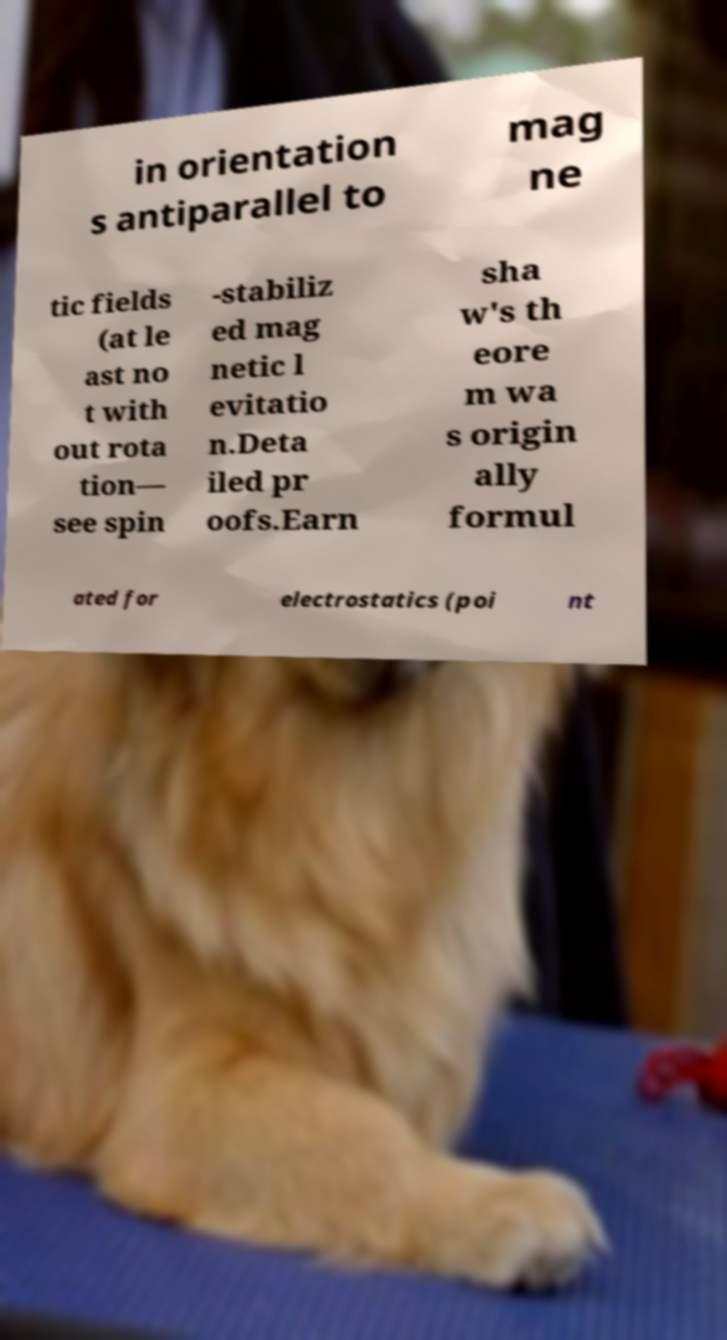There's text embedded in this image that I need extracted. Can you transcribe it verbatim? in orientation s antiparallel to mag ne tic fields (at le ast no t with out rota tion— see spin -stabiliz ed mag netic l evitatio n.Deta iled pr oofs.Earn sha w's th eore m wa s origin ally formul ated for electrostatics (poi nt 